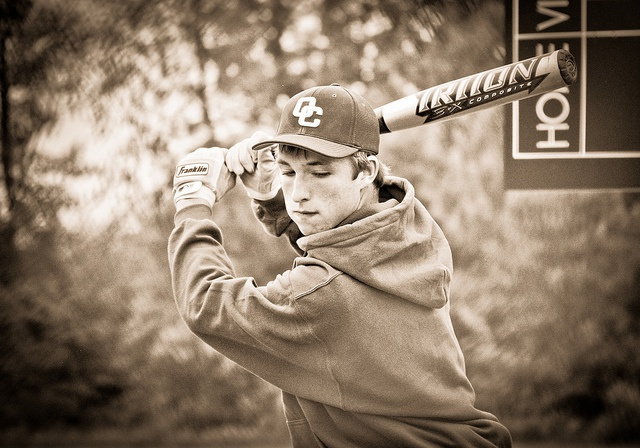Describe the objects in this image and their specific colors. I can see people in black, lightgray, gray, and tan tones and baseball bat in black, white, and gray tones in this image. 